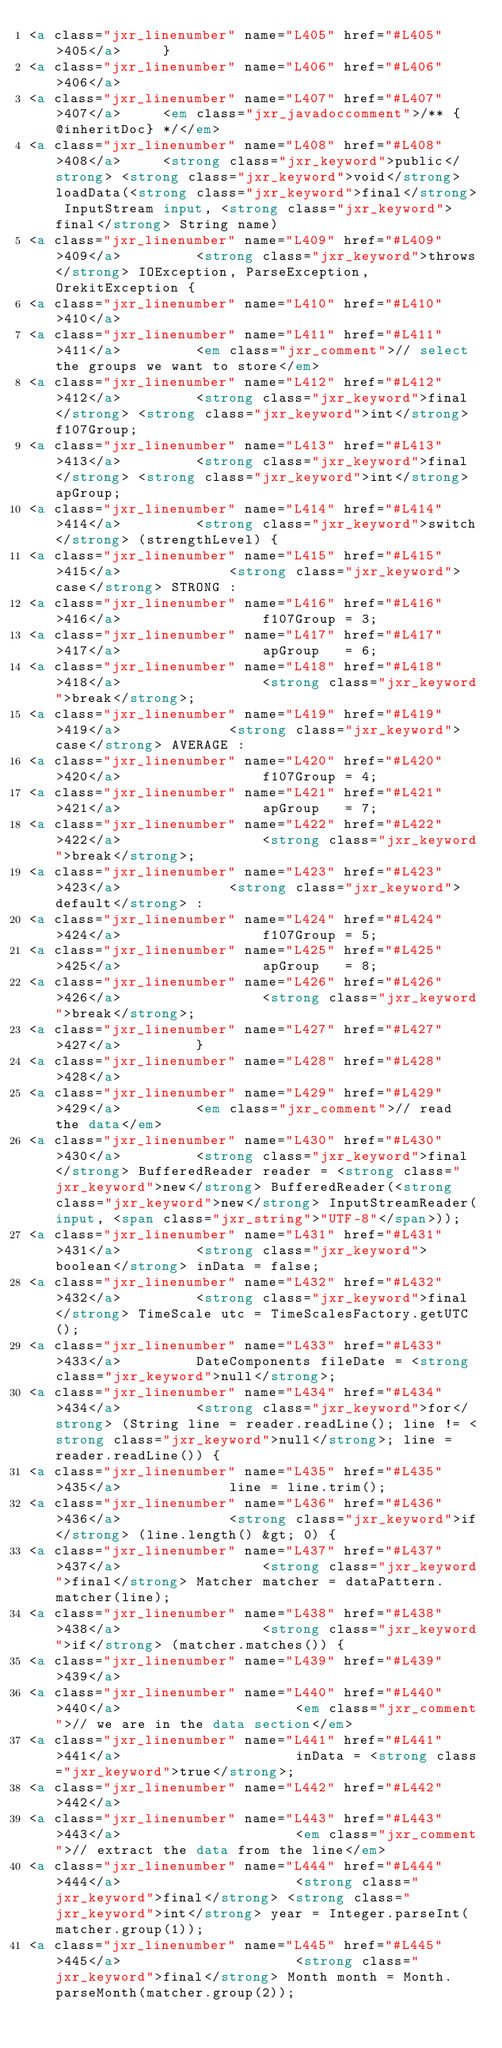Convert code to text. <code><loc_0><loc_0><loc_500><loc_500><_HTML_><a class="jxr_linenumber" name="L405" href="#L405">405</a>     }
<a class="jxr_linenumber" name="L406" href="#L406">406</a> 
<a class="jxr_linenumber" name="L407" href="#L407">407</a>     <em class="jxr_javadoccomment">/** {@inheritDoc} */</em>
<a class="jxr_linenumber" name="L408" href="#L408">408</a>     <strong class="jxr_keyword">public</strong> <strong class="jxr_keyword">void</strong> loadData(<strong class="jxr_keyword">final</strong> InputStream input, <strong class="jxr_keyword">final</strong> String name)
<a class="jxr_linenumber" name="L409" href="#L409">409</a>         <strong class="jxr_keyword">throws</strong> IOException, ParseException, OrekitException {
<a class="jxr_linenumber" name="L410" href="#L410">410</a> 
<a class="jxr_linenumber" name="L411" href="#L411">411</a>         <em class="jxr_comment">// select the groups we want to store</em>
<a class="jxr_linenumber" name="L412" href="#L412">412</a>         <strong class="jxr_keyword">final</strong> <strong class="jxr_keyword">int</strong> f107Group;
<a class="jxr_linenumber" name="L413" href="#L413">413</a>         <strong class="jxr_keyword">final</strong> <strong class="jxr_keyword">int</strong> apGroup;
<a class="jxr_linenumber" name="L414" href="#L414">414</a>         <strong class="jxr_keyword">switch</strong> (strengthLevel) {
<a class="jxr_linenumber" name="L415" href="#L415">415</a>             <strong class="jxr_keyword">case</strong> STRONG :
<a class="jxr_linenumber" name="L416" href="#L416">416</a>                 f107Group = 3;
<a class="jxr_linenumber" name="L417" href="#L417">417</a>                 apGroup   = 6;
<a class="jxr_linenumber" name="L418" href="#L418">418</a>                 <strong class="jxr_keyword">break</strong>;
<a class="jxr_linenumber" name="L419" href="#L419">419</a>             <strong class="jxr_keyword">case</strong> AVERAGE :
<a class="jxr_linenumber" name="L420" href="#L420">420</a>                 f107Group = 4;
<a class="jxr_linenumber" name="L421" href="#L421">421</a>                 apGroup   = 7;
<a class="jxr_linenumber" name="L422" href="#L422">422</a>                 <strong class="jxr_keyword">break</strong>;
<a class="jxr_linenumber" name="L423" href="#L423">423</a>             <strong class="jxr_keyword">default</strong> :
<a class="jxr_linenumber" name="L424" href="#L424">424</a>                 f107Group = 5;
<a class="jxr_linenumber" name="L425" href="#L425">425</a>                 apGroup   = 8;
<a class="jxr_linenumber" name="L426" href="#L426">426</a>                 <strong class="jxr_keyword">break</strong>;
<a class="jxr_linenumber" name="L427" href="#L427">427</a>         }
<a class="jxr_linenumber" name="L428" href="#L428">428</a> 
<a class="jxr_linenumber" name="L429" href="#L429">429</a>         <em class="jxr_comment">// read the data</em>
<a class="jxr_linenumber" name="L430" href="#L430">430</a>         <strong class="jxr_keyword">final</strong> BufferedReader reader = <strong class="jxr_keyword">new</strong> BufferedReader(<strong class="jxr_keyword">new</strong> InputStreamReader(input, <span class="jxr_string">"UTF-8"</span>));
<a class="jxr_linenumber" name="L431" href="#L431">431</a>         <strong class="jxr_keyword">boolean</strong> inData = false;
<a class="jxr_linenumber" name="L432" href="#L432">432</a>         <strong class="jxr_keyword">final</strong> TimeScale utc = TimeScalesFactory.getUTC();
<a class="jxr_linenumber" name="L433" href="#L433">433</a>         DateComponents fileDate = <strong class="jxr_keyword">null</strong>;
<a class="jxr_linenumber" name="L434" href="#L434">434</a>         <strong class="jxr_keyword">for</strong> (String line = reader.readLine(); line != <strong class="jxr_keyword">null</strong>; line = reader.readLine()) {
<a class="jxr_linenumber" name="L435" href="#L435">435</a>             line = line.trim();
<a class="jxr_linenumber" name="L436" href="#L436">436</a>             <strong class="jxr_keyword">if</strong> (line.length() &gt; 0) {
<a class="jxr_linenumber" name="L437" href="#L437">437</a>                 <strong class="jxr_keyword">final</strong> Matcher matcher = dataPattern.matcher(line);
<a class="jxr_linenumber" name="L438" href="#L438">438</a>                 <strong class="jxr_keyword">if</strong> (matcher.matches()) {
<a class="jxr_linenumber" name="L439" href="#L439">439</a> 
<a class="jxr_linenumber" name="L440" href="#L440">440</a>                     <em class="jxr_comment">// we are in the data section</em>
<a class="jxr_linenumber" name="L441" href="#L441">441</a>                     inData = <strong class="jxr_keyword">true</strong>;
<a class="jxr_linenumber" name="L442" href="#L442">442</a> 
<a class="jxr_linenumber" name="L443" href="#L443">443</a>                     <em class="jxr_comment">// extract the data from the line</em>
<a class="jxr_linenumber" name="L444" href="#L444">444</a>                     <strong class="jxr_keyword">final</strong> <strong class="jxr_keyword">int</strong> year = Integer.parseInt(matcher.group(1));
<a class="jxr_linenumber" name="L445" href="#L445">445</a>                     <strong class="jxr_keyword">final</strong> Month month = Month.parseMonth(matcher.group(2));</code> 